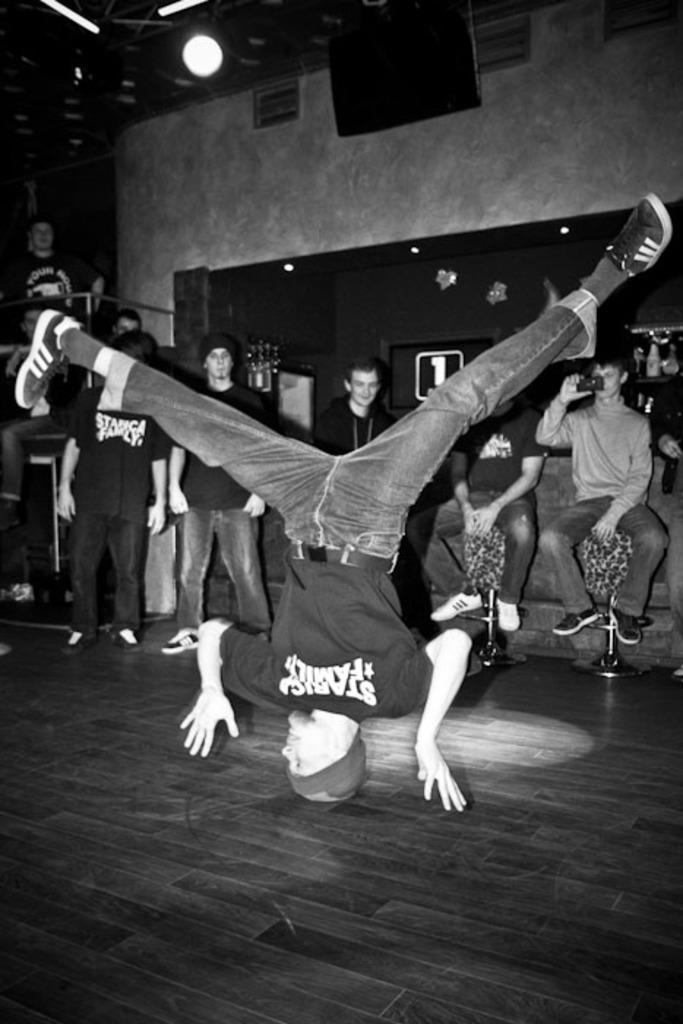How many people are in the image? There are many people standing in the image. What are some of the people in the image doing? Some people are sitting in the image. Can you describe the position of one person in the image? There is a person upside down in the image. What is the material of the floor in the image? The floor appears to be made of wood. What type of furniture is present in the image? There is a stool in the image. What is the source of light in the image? There is a light source in the image. What type of bait is being used by the person driving a car in the image? There is no person driving a car or using bait in the image. 